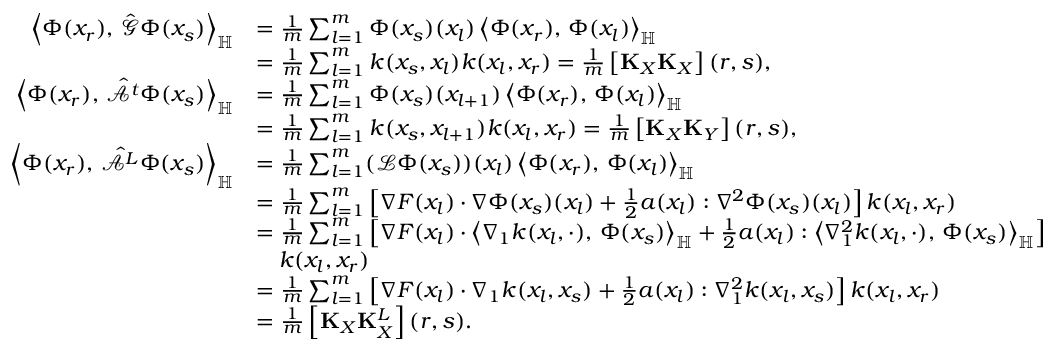Convert formula to latex. <formula><loc_0><loc_0><loc_500><loc_500>\begin{array} { r l } { \left \langle \Phi ( x _ { r } ) , \, \hat { \mathcal { G } } \Phi ( x _ { s } ) \right \rangle _ { \mathbb { H } } } & { = \frac { 1 } { m } \sum _ { l = 1 } ^ { m } \Phi ( x _ { s } ) ( x _ { l } ) \left \langle \Phi ( x _ { r } ) , \, \Phi ( x _ { l } ) \right \rangle _ { \mathbb { H } } } \\ & { = \frac { 1 } { m } \sum _ { l = 1 } ^ { m } k ( x _ { s } , x _ { l } ) k ( x _ { l } , x _ { r } ) = \frac { 1 } { m } \left [ K _ { X } K _ { X } \right ] ( r , s ) , } \\ { \left \langle \Phi ( x _ { r } ) , \, \hat { \mathcal { A } ^ { t } } \Phi ( x _ { s } ) \right \rangle _ { \mathbb { H } } } & { = \frac { 1 } { m } \sum _ { l = 1 } ^ { m } \Phi ( x _ { s } ) ( x _ { l + 1 } ) \left \langle \Phi ( x _ { r } ) , \, \Phi ( x _ { l } ) \right \rangle _ { \mathbb { H } } } \\ & { = \frac { 1 } { m } \sum _ { l = 1 } ^ { m } k ( x _ { s } , x _ { l + 1 } ) k ( x _ { l } , x _ { r } ) = \frac { 1 } { m } \left [ K _ { X } K _ { Y } \right ] ( r , s ) , } \\ { \left \langle \Phi ( x _ { r } ) , \, \hat { \mathcal { A } ^ { L } } \Phi ( x _ { s } ) \right \rangle _ { \mathbb { H } } } & { = \frac { 1 } { m } \sum _ { l = 1 } ^ { m } ( \mathcal { L } \Phi ( x _ { s } ) ) ( x _ { l } ) \left \langle \Phi ( x _ { r } ) , \, \Phi ( x _ { l } ) \right \rangle _ { \mathbb { H } } } \\ & { = \frac { 1 } { m } \sum _ { l = 1 } ^ { m } \left [ \nabla F ( x _ { l } ) \cdot \nabla \Phi ( x _ { s } ) ( x _ { l } ) + \frac { 1 } { 2 } a ( x _ { l } ) \colon \nabla ^ { 2 } \Phi ( x _ { s } ) ( x _ { l } ) \right ] k ( x _ { l } , x _ { r } ) } \\ & { = \frac { 1 } { m } \sum _ { l = 1 } ^ { m } \left [ \nabla F ( x _ { l } ) \cdot \left \langle \nabla _ { 1 } k ( x _ { l } , \cdot ) , \, \Phi ( x _ { s } ) \right \rangle _ { \mathbb { H } } + \frac { 1 } { 2 } a ( x _ { l } ) \colon \left \langle \nabla _ { 1 } ^ { 2 } k ( x _ { l } , \cdot ) , \, \Phi ( x _ { s } ) \right \rangle _ { \mathbb { H } } \right ] } \\ & { \quad k ( x _ { l } , x _ { r } ) } \\ & { = \frac { 1 } { m } \sum _ { l = 1 } ^ { m } \left [ \nabla F ( x _ { l } ) \cdot \nabla _ { 1 } k ( x _ { l } , x _ { s } ) + \frac { 1 } { 2 } a ( x _ { l } ) \colon \nabla _ { 1 } ^ { 2 } k ( x _ { l } , x _ { s } ) \right ] k ( x _ { l } , x _ { r } ) } \\ & { = \frac { 1 } { m } \left [ K _ { X } K _ { X } ^ { L } \right ] ( r , s ) . } \end{array}</formula> 